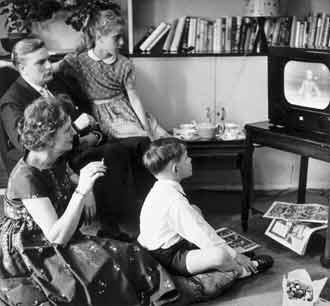Question: where is the tea set?
Choices:
A. On the counter.
B. On the chair.
C. On the shelf.
D. On the table.
Answer with the letter. Answer: D Question: how many people are in the photograph watching TV?
Choices:
A. Three.
B. Four.
C. Five.
D. Six.
Answer with the letter. Answer: B Question: what is on the shelf?
Choices:
A. Vase and cups.
B. Glasses and silverware.
C. Plants and photos.
D. Books and a lamp.
Answer with the letter. Answer: D Question: what color is the photograph?
Choices:
A. Chrome color.
B. Bright colors.
C. Black and white.
D. Red white and blue.
Answer with the letter. Answer: C Question: what are the people doing in the photo?
Choices:
A. Eating food.
B. Playing video games.
C. Listening to music.
D. Watching TV.
Answer with the letter. Answer: D Question: who is in the photograph?
Choices:
A. A family.
B. A boy.
C. A dog.
D. A woman.
Answer with the letter. Answer: A 